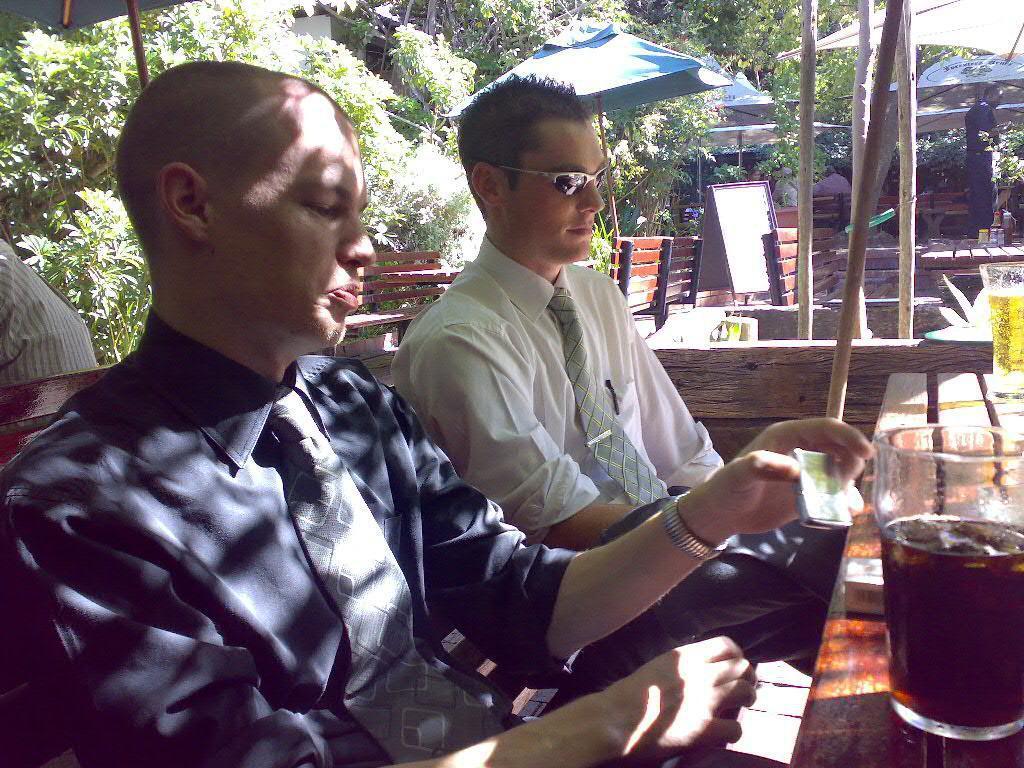Can you describe this image briefly? In this picture we can see group of people, few are sitting on the benches and a man is standing, on the right side of the image we can find glasses on the table and we can see drink in the glasses, in the background we can find few trees and umbrellas. 